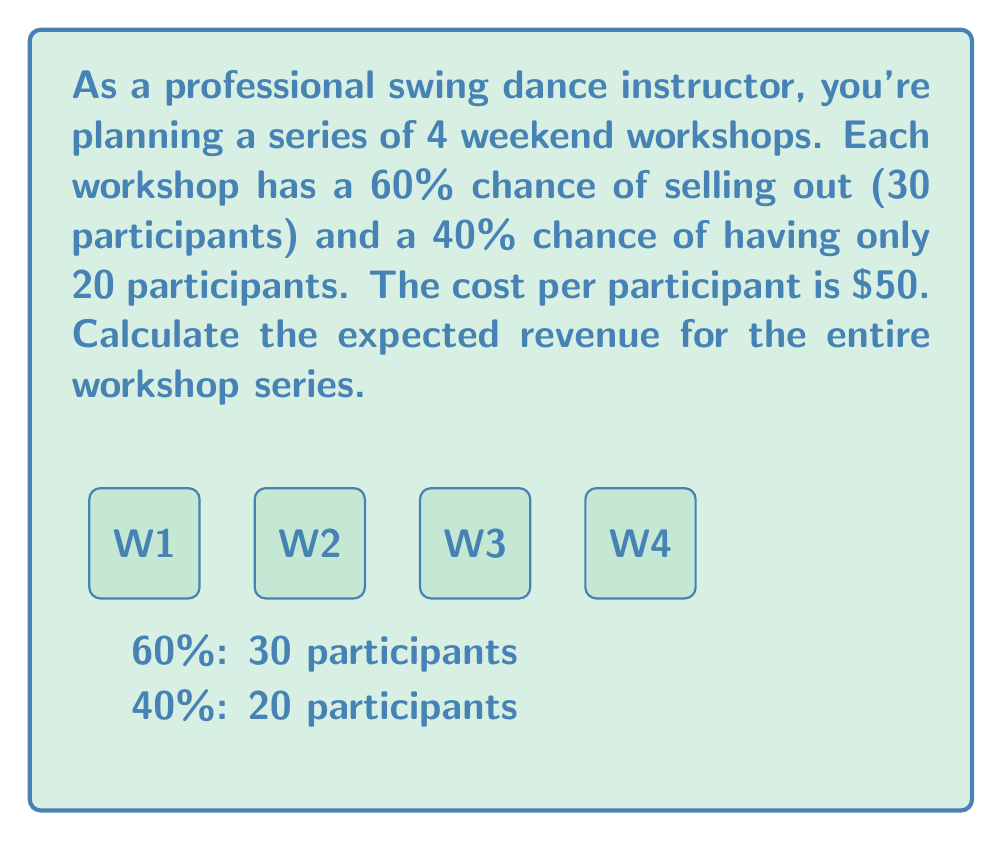Provide a solution to this math problem. Let's approach this step-by-step:

1) First, let's calculate the expected revenue for a single workshop:

   - If it sells out (30 participants): $30 \times \$50 = \$1500$
   - If it has 20 participants: $20 \times \$50 = \$1000$

2) The expected value for a single workshop is:

   $E(\text{single workshop}) = 0.60 \times \$1500 + 0.40 \times \$1000$

3) Let's calculate this:

   $E(\text{single workshop}) = \$900 + \$400 = \$1300$

4) Now, since there are 4 workshops and they are independent events, we can multiply the expected value of a single workshop by 4:

   $E(\text{series}) = 4 \times E(\text{single workshop})$

5) Substituting the value we calculated:

   $E(\text{series}) = 4 \times \$1300 = \$5200$

Therefore, the expected revenue for the entire workshop series is $5200.
Answer: $5200 